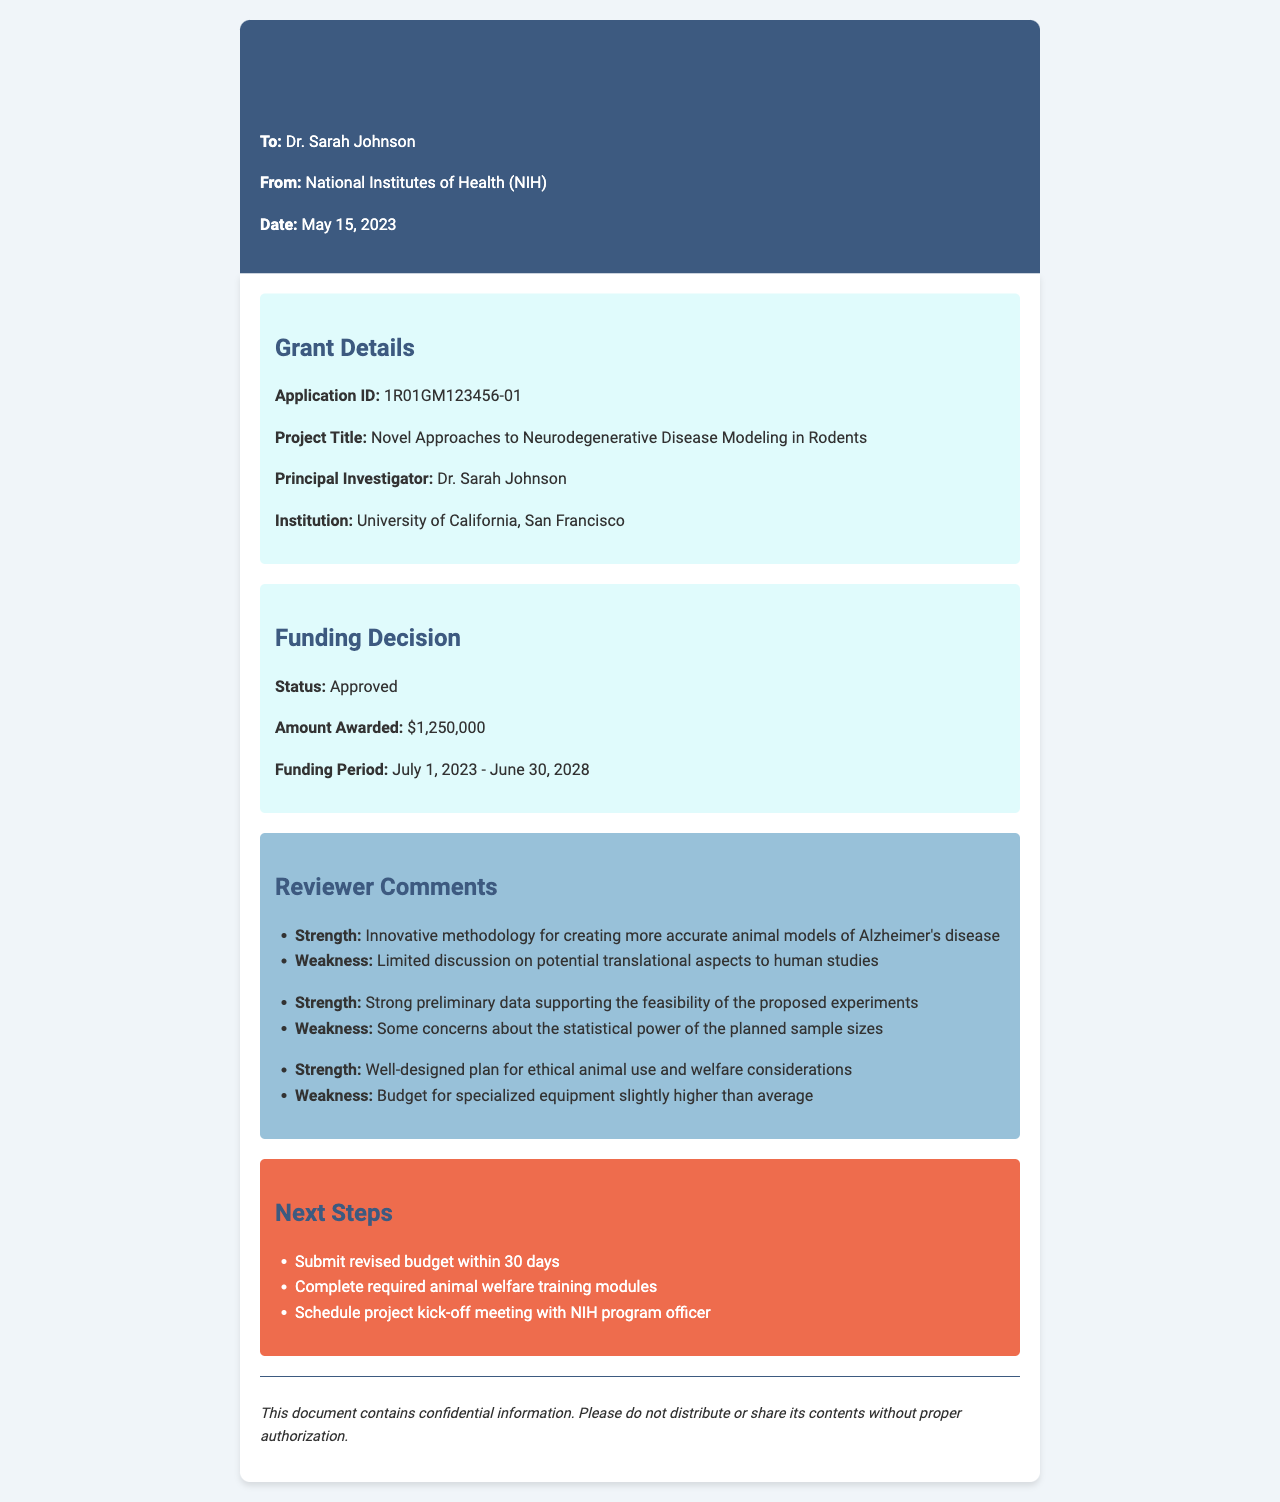What is the application ID? The application ID can be found in the grant details section of the document.
Answer: 1R01GM123456-01 What is the project title? The project title is mentioned in the grant details section.
Answer: Novel Approaches to Neurodegenerative Disease Modeling in Rodents Who is the principal investigator? The principal investigator's name is provided in the grant details.
Answer: Dr. Sarah Johnson What is the amount awarded for the grant? The funding decision section provides the amount awarded.
Answer: $1,250,000 What are the dates for the funding period? The funding period dates are indicated in the funding decision section.
Answer: July 1, 2023 - June 30, 2028 What is a strength mentioned by the reviewers? Reviewer comments outline various strengths, one of which can be identified.
Answer: Innovative methodology for creating more accurate animal models of Alzheimer's disease What is a weakness regarding statistical power? The weakness related to statistical power is noted in the reviewer comments.
Answer: Some concerns about the statistical power of the planned sample sizes What are the next steps to be taken? The next steps are listed in the corresponding section of the document.
Answer: Submit revised budget within 30 days What is the purpose of the confidentiality notice? The confidentiality notice informs about the document's sensitivity.
Answer: Confidential information What organization is this fax from? The sender's information in the document specifies the issuing organization.
Answer: National Institutes of Health (NIH) 